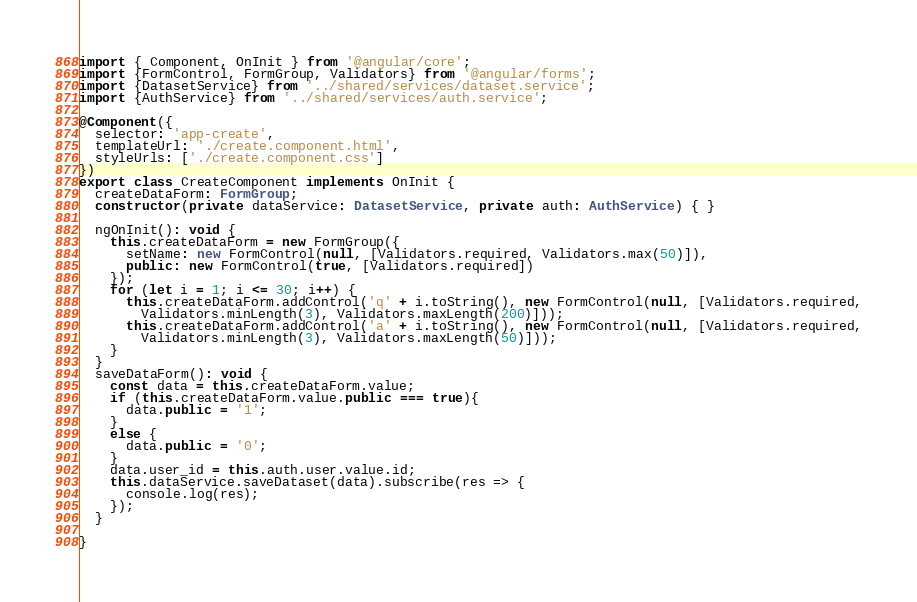Convert code to text. <code><loc_0><loc_0><loc_500><loc_500><_TypeScript_>import { Component, OnInit } from '@angular/core';
import {FormControl, FormGroup, Validators} from '@angular/forms';
import {DatasetService} from '../shared/services/dataset.service';
import {AuthService} from '../shared/services/auth.service';

@Component({
  selector: 'app-create',
  templateUrl: './create.component.html',
  styleUrls: ['./create.component.css']
})
export class CreateComponent implements OnInit {
  createDataForm: FormGroup;
  constructor(private dataService: DatasetService, private auth: AuthService) { }

  ngOnInit(): void {
    this.createDataForm = new FormGroup({
      setName: new FormControl(null, [Validators.required, Validators.max(50)]),
      public: new FormControl(true, [Validators.required])
    });
    for (let i = 1; i <= 30; i++) {
      this.createDataForm.addControl('q' + i.toString(), new FormControl(null, [Validators.required,
        Validators.minLength(3), Validators.maxLength(200)]));
      this.createDataForm.addControl('a' + i.toString(), new FormControl(null, [Validators.required,
        Validators.minLength(3), Validators.maxLength(50)]));
    }
  }
  saveDataForm(): void {
    const data = this.createDataForm.value;
    if (this.createDataForm.value.public === true){
      data.public = '1';
    }
    else {
      data.public = '0';
    }
    data.user_id = this.auth.user.value.id;
    this.dataService.saveDataset(data).subscribe(res => {
      console.log(res);
    });
  }

}
</code> 